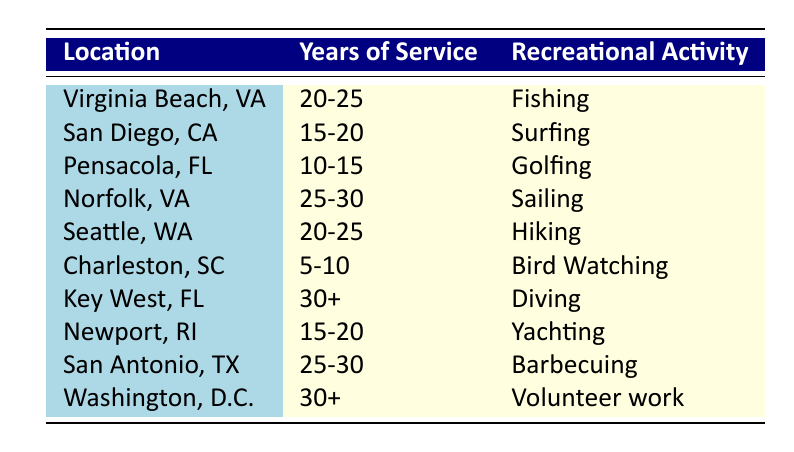What is the recreational activity pursued by retired naval officers in Norfolk, VA? Looking at the row for Norfolk, VA, the recreational activity listed is Sailing.
Answer: Sailing Which city has retired naval officers who enjoy Golfing? Referring to the table, Golfing is pursued in Pensacola, FL.
Answer: Pensacola, FL How many different recreational activities are listed for retired naval officers in the data? By scanning the table, the unique activities noted are Fishing, Surfing, Golfing, Sailing, Hiking, Bird Watching, Diving, Yachting, Barbecuing, and Volunteer work, totaling 10 activities.
Answer: 10 Is there any location where retired naval officers practice Bird Watching? The table shows that Bird Watching is specifically pursued in Charleston, SC. Thus, the answer is yes.
Answer: Yes How many activities are associated with years of service 30+? There are two activities for years of service 30+, namely Diving in Key West, FL, and Volunteer work in Washington, D.C. Adding them together results in 2.
Answer: 2 Which city has the longest service years (30+) and what is the recreational activity associated with it? Looking at the rows, Key West, FL and Washington, D.C. have activities aligned with 30+ years. Key West, FL's activity is Diving and Washington, D.C.'s is Volunteer work. Therefore, the longest years indicate both locations with their respective activities being noted.
Answer: Key West, FL (Diving) and Washington, D.C. (Volunteer work) What is the difference in years of service between the longest servicer (30+) and the shortest (5-10)? The shortest years of service is 5-10, while the longest is 30+. To find the difference, 30 - 5 = 25 years as an approximation of the years.
Answer: 25 years Are there retired officers who enjoy Yachting in Virginia Beach, VA? The table indicates that Yachting occurs in Newport, RI, whereas Virginia Beach, VA has Fishing as the activity. Therefore, the answer is no.
Answer: No 